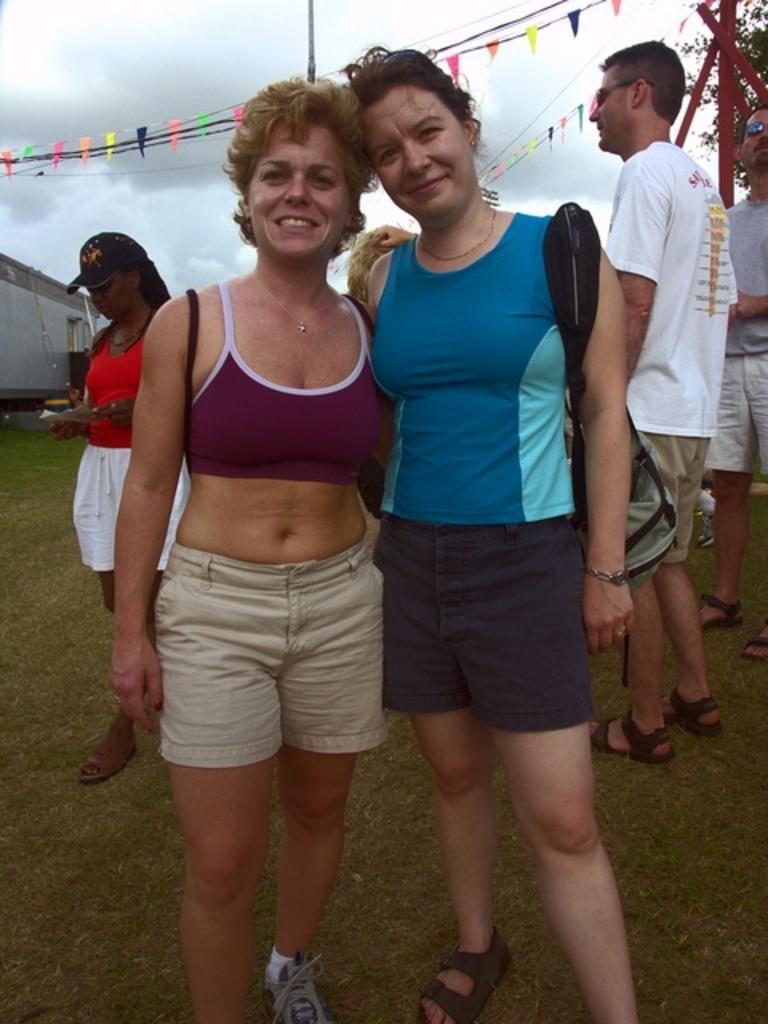Please provide a concise description of this image. There are two women standing. Lady on the right is holding a bag. In the back there are few people. Another lady is wearing a cap. In the background there is sky. And there are some decorative items. 